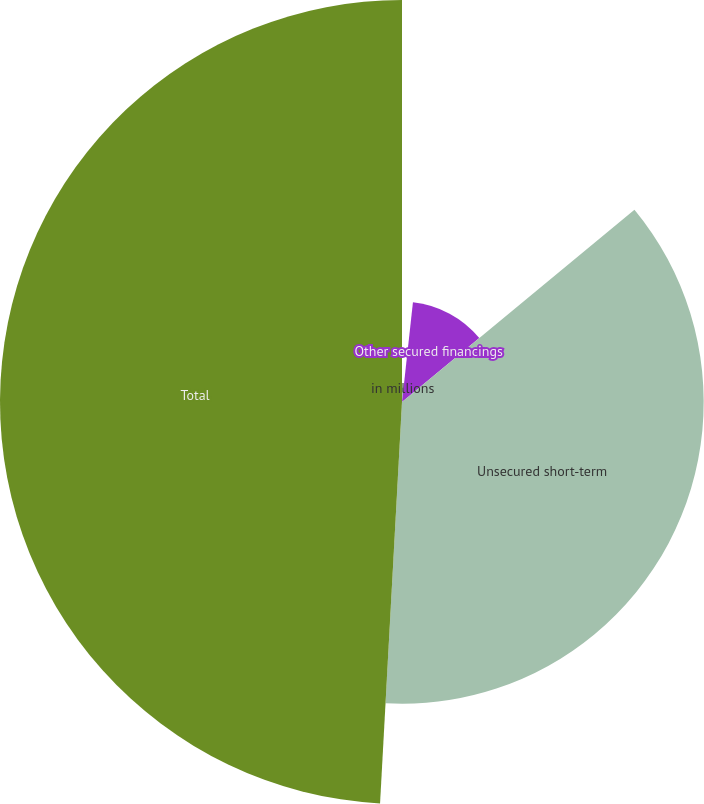Convert chart to OTSL. <chart><loc_0><loc_0><loc_500><loc_500><pie_chart><fcel>in millions<fcel>Other secured financings<fcel>Unsecured short-term<fcel>Total<nl><fcel>1.74%<fcel>12.26%<fcel>36.87%<fcel>49.13%<nl></chart> 